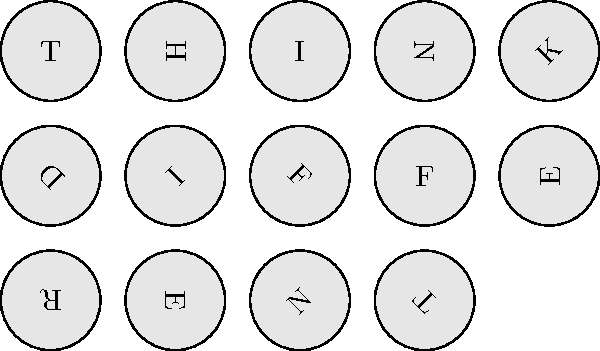In this mental rotation task, typewriter keys are arranged to spell out a famous advertising slogan. Each key is rotated at a different angle. If you were to mentally rotate these keys to their upright positions, what well-known catchphrase would you see? To solve this mental rotation task, follow these steps:

1. Identify each letter on the typewriter keys, regardless of their rotation:
   Row 1: T, H, I, N, K
   Row 2: D, I, F, F, E
   Row 3: R, E, N, T

2. Mentally rotate each key to its upright position:
   - The 'T' key is already upright
   - The 'H' key needs to be rotated 90° counterclockwise
   - The 'I' key needs to be rotated 180°
   - And so on for each key

3. Read the letters in order from left to right, top to bottom:
   Row 1: THINK
   Row 2: DIFFE
   Row 3: RENT

4. Combine the rows to form the complete phrase:
   THINK DIFFERENT

This catchphrase is the famous slogan used by Apple Inc. in their advertising campaign from 1997 to 2002, which would be familiar to a former copywriter in the advertising industry.
Answer: Think Different 